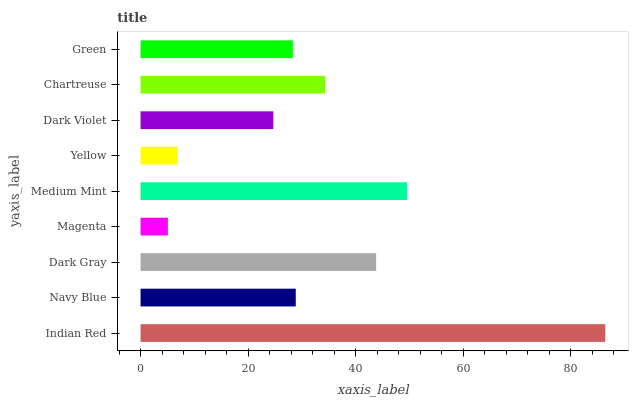Is Magenta the minimum?
Answer yes or no. Yes. Is Indian Red the maximum?
Answer yes or no. Yes. Is Navy Blue the minimum?
Answer yes or no. No. Is Navy Blue the maximum?
Answer yes or no. No. Is Indian Red greater than Navy Blue?
Answer yes or no. Yes. Is Navy Blue less than Indian Red?
Answer yes or no. Yes. Is Navy Blue greater than Indian Red?
Answer yes or no. No. Is Indian Red less than Navy Blue?
Answer yes or no. No. Is Navy Blue the high median?
Answer yes or no. Yes. Is Navy Blue the low median?
Answer yes or no. Yes. Is Chartreuse the high median?
Answer yes or no. No. Is Magenta the low median?
Answer yes or no. No. 